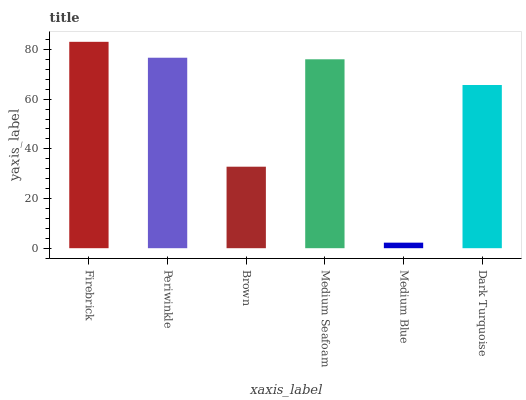Is Periwinkle the minimum?
Answer yes or no. No. Is Periwinkle the maximum?
Answer yes or no. No. Is Firebrick greater than Periwinkle?
Answer yes or no. Yes. Is Periwinkle less than Firebrick?
Answer yes or no. Yes. Is Periwinkle greater than Firebrick?
Answer yes or no. No. Is Firebrick less than Periwinkle?
Answer yes or no. No. Is Medium Seafoam the high median?
Answer yes or no. Yes. Is Dark Turquoise the low median?
Answer yes or no. Yes. Is Firebrick the high median?
Answer yes or no. No. Is Firebrick the low median?
Answer yes or no. No. 